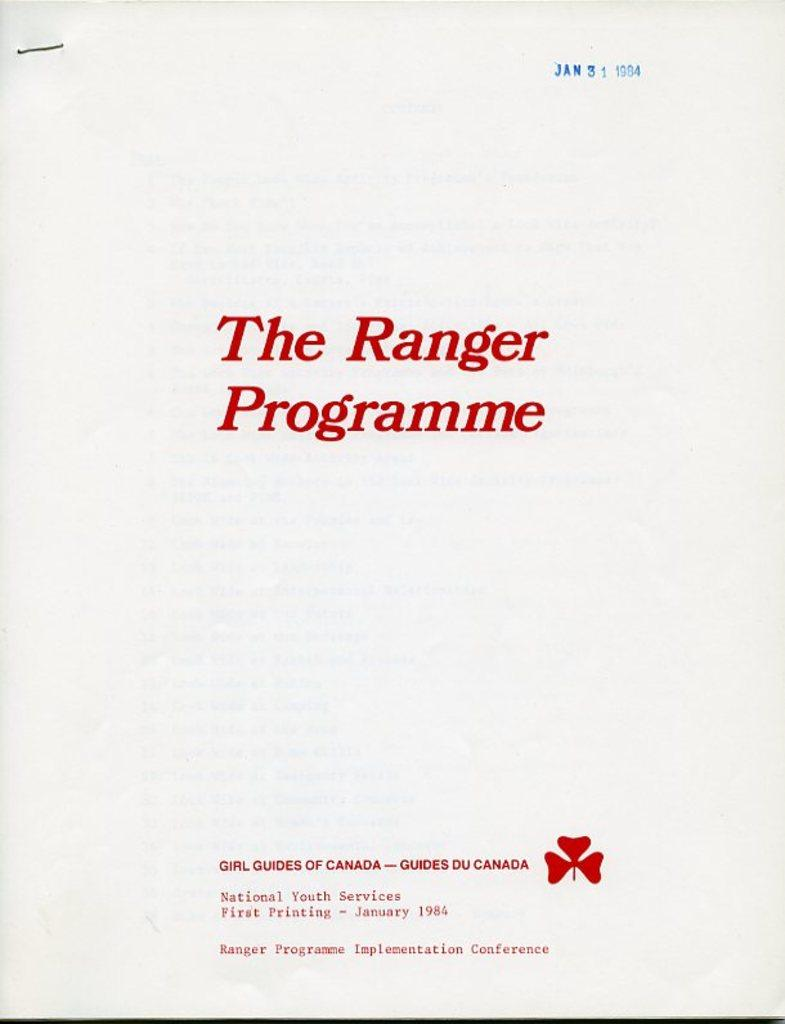<image>
Summarize the visual content of the image. In bright red letters a packet of papers is labeled The Ranger Programme. 